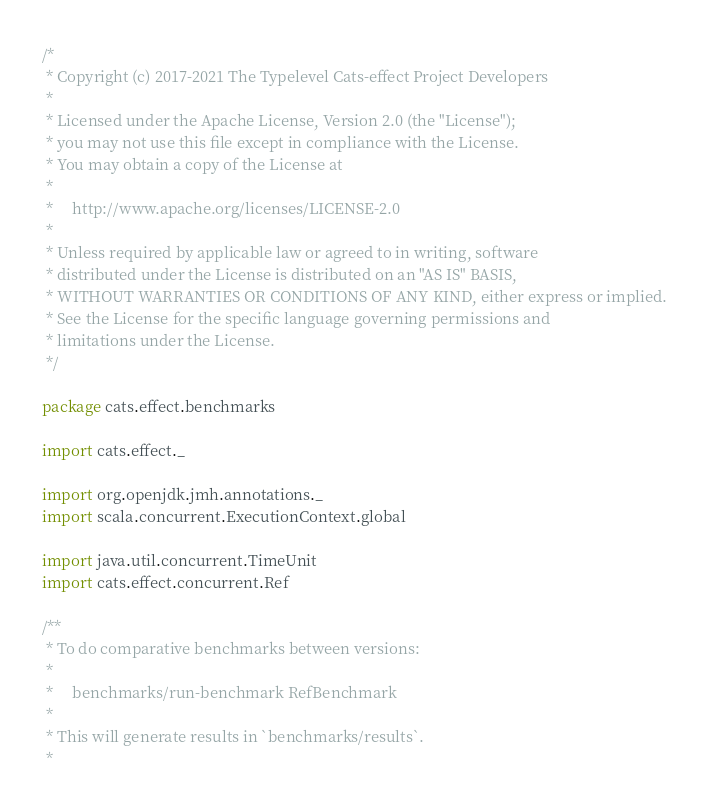<code> <loc_0><loc_0><loc_500><loc_500><_Scala_>/*
 * Copyright (c) 2017-2021 The Typelevel Cats-effect Project Developers
 *
 * Licensed under the Apache License, Version 2.0 (the "License");
 * you may not use this file except in compliance with the License.
 * You may obtain a copy of the License at
 *
 *     http://www.apache.org/licenses/LICENSE-2.0
 *
 * Unless required by applicable law or agreed to in writing, software
 * distributed under the License is distributed on an "AS IS" BASIS,
 * WITHOUT WARRANTIES OR CONDITIONS OF ANY KIND, either express or implied.
 * See the License for the specific language governing permissions and
 * limitations under the License.
 */

package cats.effect.benchmarks

import cats.effect._

import org.openjdk.jmh.annotations._
import scala.concurrent.ExecutionContext.global

import java.util.concurrent.TimeUnit
import cats.effect.concurrent.Ref

/**
 * To do comparative benchmarks between versions:
 *
 *     benchmarks/run-benchmark RefBenchmark
 *
 * This will generate results in `benchmarks/results`.
 *</code> 